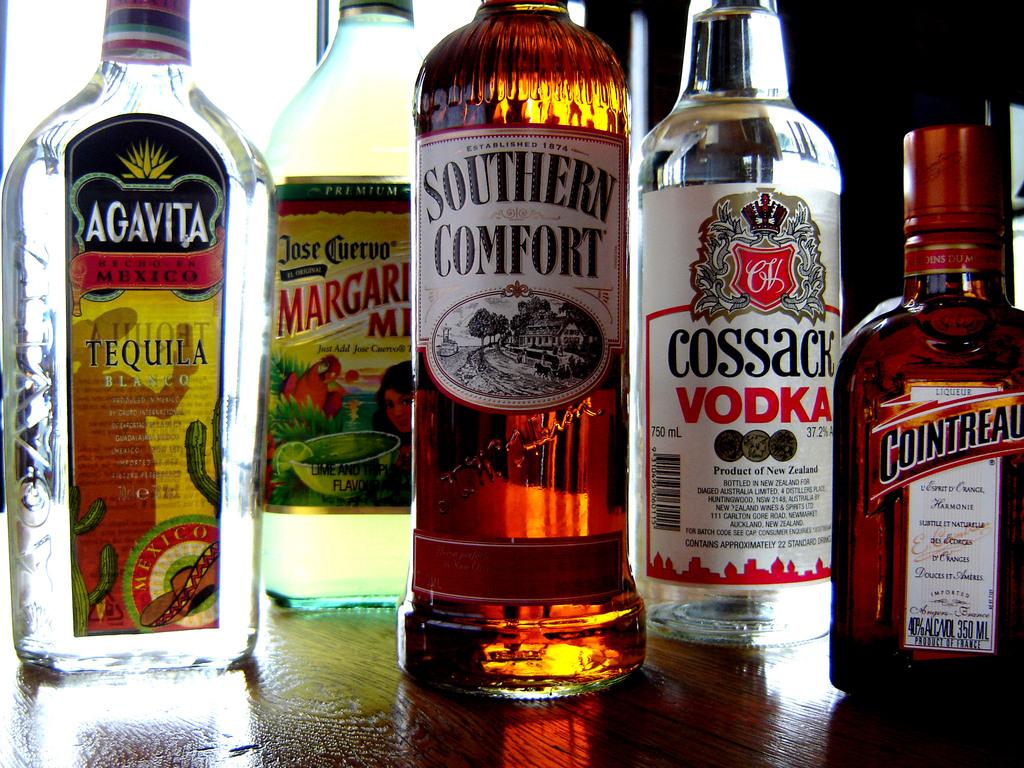What types of liquor are there?
Provide a succinct answer. Tequila, vidka. What is the beverage in the middle?
Offer a terse response. Southern comfort. 